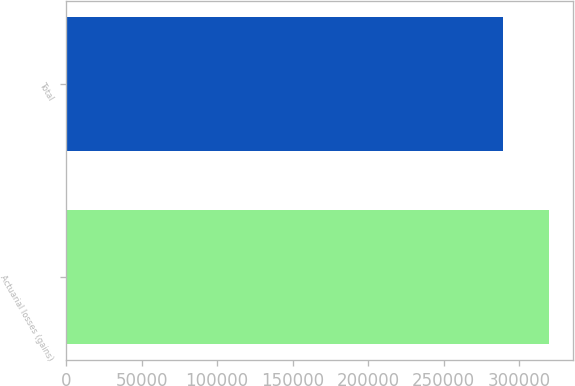<chart> <loc_0><loc_0><loc_500><loc_500><bar_chart><fcel>Actuarial losses (gains)<fcel>Total<nl><fcel>319770<fcel>289628<nl></chart> 